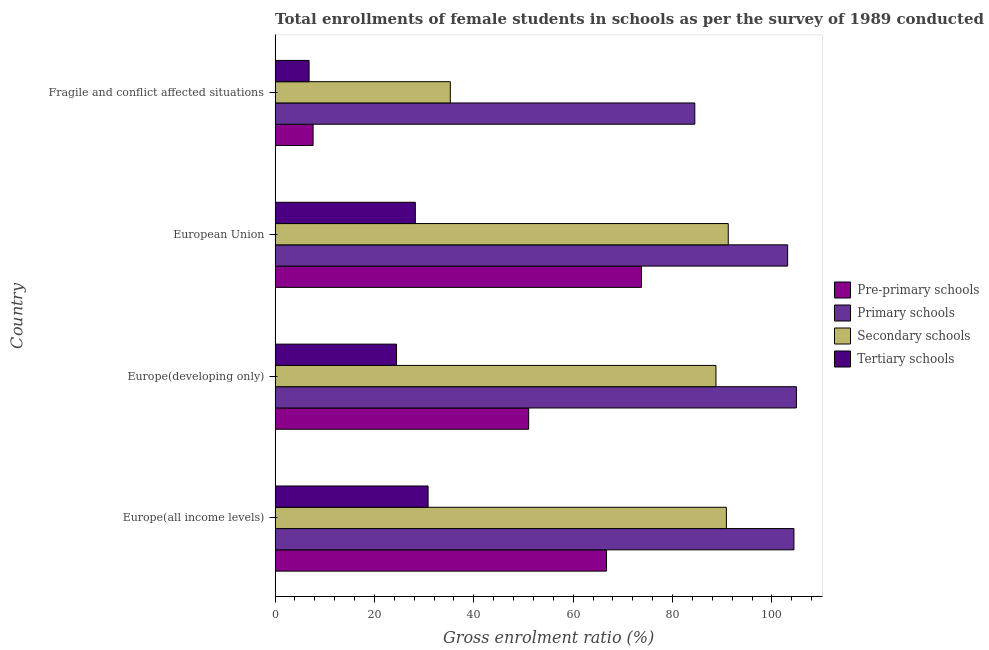Are the number of bars per tick equal to the number of legend labels?
Keep it short and to the point. Yes. How many bars are there on the 1st tick from the top?
Give a very brief answer. 4. What is the label of the 4th group of bars from the top?
Your response must be concise. Europe(all income levels). What is the gross enrolment ratio(female) in tertiary schools in Europe(developing only)?
Your response must be concise. 24.45. Across all countries, what is the maximum gross enrolment ratio(female) in primary schools?
Offer a very short reply. 104.92. Across all countries, what is the minimum gross enrolment ratio(female) in primary schools?
Your answer should be compact. 84.47. In which country was the gross enrolment ratio(female) in primary schools maximum?
Ensure brevity in your answer.  Europe(developing only). In which country was the gross enrolment ratio(female) in tertiary schools minimum?
Provide a short and direct response. Fragile and conflict affected situations. What is the total gross enrolment ratio(female) in pre-primary schools in the graph?
Keep it short and to the point. 199.14. What is the difference between the gross enrolment ratio(female) in primary schools in Europe(all income levels) and that in European Union?
Your answer should be compact. 1.26. What is the difference between the gross enrolment ratio(female) in tertiary schools in Europe(developing only) and the gross enrolment ratio(female) in pre-primary schools in European Union?
Give a very brief answer. -49.29. What is the average gross enrolment ratio(female) in pre-primary schools per country?
Give a very brief answer. 49.78. What is the difference between the gross enrolment ratio(female) in secondary schools and gross enrolment ratio(female) in pre-primary schools in European Union?
Provide a succinct answer. 17.46. In how many countries, is the gross enrolment ratio(female) in secondary schools greater than 16 %?
Provide a succinct answer. 4. What is the ratio of the gross enrolment ratio(female) in pre-primary schools in Europe(all income levels) to that in Europe(developing only)?
Give a very brief answer. 1.31. Is the gross enrolment ratio(female) in pre-primary schools in European Union less than that in Fragile and conflict affected situations?
Provide a succinct answer. No. Is the difference between the gross enrolment ratio(female) in tertiary schools in Europe(developing only) and European Union greater than the difference between the gross enrolment ratio(female) in secondary schools in Europe(developing only) and European Union?
Provide a succinct answer. No. What is the difference between the highest and the second highest gross enrolment ratio(female) in primary schools?
Provide a succinct answer. 0.5. What is the difference between the highest and the lowest gross enrolment ratio(female) in primary schools?
Offer a terse response. 20.45. Is the sum of the gross enrolment ratio(female) in tertiary schools in Europe(all income levels) and Fragile and conflict affected situations greater than the maximum gross enrolment ratio(female) in primary schools across all countries?
Make the answer very short. No. What does the 1st bar from the top in Fragile and conflict affected situations represents?
Provide a succinct answer. Tertiary schools. What does the 3rd bar from the bottom in Europe(developing only) represents?
Provide a succinct answer. Secondary schools. How many bars are there?
Provide a succinct answer. 16. Are all the bars in the graph horizontal?
Provide a succinct answer. Yes. Are the values on the major ticks of X-axis written in scientific E-notation?
Give a very brief answer. No. Where does the legend appear in the graph?
Keep it short and to the point. Center right. How many legend labels are there?
Offer a very short reply. 4. How are the legend labels stacked?
Offer a terse response. Vertical. What is the title of the graph?
Your answer should be very brief. Total enrollments of female students in schools as per the survey of 1989 conducted in different countries. Does "Source data assessment" appear as one of the legend labels in the graph?
Keep it short and to the point. No. What is the label or title of the X-axis?
Offer a terse response. Gross enrolment ratio (%). What is the label or title of the Y-axis?
Offer a terse response. Country. What is the Gross enrolment ratio (%) in Pre-primary schools in Europe(all income levels)?
Provide a short and direct response. 66.71. What is the Gross enrolment ratio (%) of Primary schools in Europe(all income levels)?
Make the answer very short. 104.42. What is the Gross enrolment ratio (%) in Secondary schools in Europe(all income levels)?
Your answer should be compact. 90.83. What is the Gross enrolment ratio (%) of Tertiary schools in Europe(all income levels)?
Your response must be concise. 30.79. What is the Gross enrolment ratio (%) in Pre-primary schools in Europe(developing only)?
Offer a terse response. 51.04. What is the Gross enrolment ratio (%) of Primary schools in Europe(developing only)?
Offer a very short reply. 104.92. What is the Gross enrolment ratio (%) of Secondary schools in Europe(developing only)?
Your response must be concise. 88.73. What is the Gross enrolment ratio (%) in Tertiary schools in Europe(developing only)?
Your answer should be compact. 24.45. What is the Gross enrolment ratio (%) in Pre-primary schools in European Union?
Offer a terse response. 73.74. What is the Gross enrolment ratio (%) in Primary schools in European Union?
Offer a terse response. 103.16. What is the Gross enrolment ratio (%) of Secondary schools in European Union?
Ensure brevity in your answer.  91.2. What is the Gross enrolment ratio (%) of Tertiary schools in European Union?
Provide a succinct answer. 28.23. What is the Gross enrolment ratio (%) of Pre-primary schools in Fragile and conflict affected situations?
Provide a short and direct response. 7.65. What is the Gross enrolment ratio (%) of Primary schools in Fragile and conflict affected situations?
Offer a very short reply. 84.47. What is the Gross enrolment ratio (%) in Secondary schools in Fragile and conflict affected situations?
Give a very brief answer. 35.27. What is the Gross enrolment ratio (%) in Tertiary schools in Fragile and conflict affected situations?
Your response must be concise. 6.84. Across all countries, what is the maximum Gross enrolment ratio (%) of Pre-primary schools?
Offer a very short reply. 73.74. Across all countries, what is the maximum Gross enrolment ratio (%) of Primary schools?
Ensure brevity in your answer.  104.92. Across all countries, what is the maximum Gross enrolment ratio (%) in Secondary schools?
Give a very brief answer. 91.2. Across all countries, what is the maximum Gross enrolment ratio (%) of Tertiary schools?
Offer a very short reply. 30.79. Across all countries, what is the minimum Gross enrolment ratio (%) of Pre-primary schools?
Make the answer very short. 7.65. Across all countries, what is the minimum Gross enrolment ratio (%) in Primary schools?
Offer a very short reply. 84.47. Across all countries, what is the minimum Gross enrolment ratio (%) in Secondary schools?
Make the answer very short. 35.27. Across all countries, what is the minimum Gross enrolment ratio (%) in Tertiary schools?
Provide a short and direct response. 6.84. What is the total Gross enrolment ratio (%) of Pre-primary schools in the graph?
Provide a succinct answer. 199.14. What is the total Gross enrolment ratio (%) of Primary schools in the graph?
Your answer should be compact. 396.97. What is the total Gross enrolment ratio (%) of Secondary schools in the graph?
Make the answer very short. 306.02. What is the total Gross enrolment ratio (%) of Tertiary schools in the graph?
Give a very brief answer. 90.31. What is the difference between the Gross enrolment ratio (%) in Pre-primary schools in Europe(all income levels) and that in Europe(developing only)?
Make the answer very short. 15.67. What is the difference between the Gross enrolment ratio (%) of Primary schools in Europe(all income levels) and that in Europe(developing only)?
Keep it short and to the point. -0.5. What is the difference between the Gross enrolment ratio (%) of Secondary schools in Europe(all income levels) and that in Europe(developing only)?
Your answer should be compact. 2.1. What is the difference between the Gross enrolment ratio (%) in Tertiary schools in Europe(all income levels) and that in Europe(developing only)?
Make the answer very short. 6.35. What is the difference between the Gross enrolment ratio (%) in Pre-primary schools in Europe(all income levels) and that in European Union?
Your response must be concise. -7.03. What is the difference between the Gross enrolment ratio (%) of Primary schools in Europe(all income levels) and that in European Union?
Offer a terse response. 1.26. What is the difference between the Gross enrolment ratio (%) of Secondary schools in Europe(all income levels) and that in European Union?
Your response must be concise. -0.37. What is the difference between the Gross enrolment ratio (%) in Tertiary schools in Europe(all income levels) and that in European Union?
Keep it short and to the point. 2.57. What is the difference between the Gross enrolment ratio (%) in Pre-primary schools in Europe(all income levels) and that in Fragile and conflict affected situations?
Your answer should be very brief. 59.05. What is the difference between the Gross enrolment ratio (%) in Primary schools in Europe(all income levels) and that in Fragile and conflict affected situations?
Offer a very short reply. 19.95. What is the difference between the Gross enrolment ratio (%) in Secondary schools in Europe(all income levels) and that in Fragile and conflict affected situations?
Your answer should be compact. 55.56. What is the difference between the Gross enrolment ratio (%) of Tertiary schools in Europe(all income levels) and that in Fragile and conflict affected situations?
Make the answer very short. 23.95. What is the difference between the Gross enrolment ratio (%) of Pre-primary schools in Europe(developing only) and that in European Union?
Keep it short and to the point. -22.7. What is the difference between the Gross enrolment ratio (%) of Primary schools in Europe(developing only) and that in European Union?
Your answer should be compact. 1.76. What is the difference between the Gross enrolment ratio (%) in Secondary schools in Europe(developing only) and that in European Union?
Give a very brief answer. -2.48. What is the difference between the Gross enrolment ratio (%) of Tertiary schools in Europe(developing only) and that in European Union?
Provide a short and direct response. -3.78. What is the difference between the Gross enrolment ratio (%) in Pre-primary schools in Europe(developing only) and that in Fragile and conflict affected situations?
Your answer should be compact. 43.38. What is the difference between the Gross enrolment ratio (%) in Primary schools in Europe(developing only) and that in Fragile and conflict affected situations?
Ensure brevity in your answer.  20.45. What is the difference between the Gross enrolment ratio (%) of Secondary schools in Europe(developing only) and that in Fragile and conflict affected situations?
Keep it short and to the point. 53.46. What is the difference between the Gross enrolment ratio (%) in Tertiary schools in Europe(developing only) and that in Fragile and conflict affected situations?
Your answer should be very brief. 17.6. What is the difference between the Gross enrolment ratio (%) of Pre-primary schools in European Union and that in Fragile and conflict affected situations?
Ensure brevity in your answer.  66.09. What is the difference between the Gross enrolment ratio (%) in Primary schools in European Union and that in Fragile and conflict affected situations?
Your answer should be very brief. 18.69. What is the difference between the Gross enrolment ratio (%) in Secondary schools in European Union and that in Fragile and conflict affected situations?
Your answer should be very brief. 55.94. What is the difference between the Gross enrolment ratio (%) of Tertiary schools in European Union and that in Fragile and conflict affected situations?
Your answer should be compact. 21.38. What is the difference between the Gross enrolment ratio (%) of Pre-primary schools in Europe(all income levels) and the Gross enrolment ratio (%) of Primary schools in Europe(developing only)?
Keep it short and to the point. -38.21. What is the difference between the Gross enrolment ratio (%) in Pre-primary schools in Europe(all income levels) and the Gross enrolment ratio (%) in Secondary schools in Europe(developing only)?
Provide a succinct answer. -22.02. What is the difference between the Gross enrolment ratio (%) in Pre-primary schools in Europe(all income levels) and the Gross enrolment ratio (%) in Tertiary schools in Europe(developing only)?
Offer a terse response. 42.26. What is the difference between the Gross enrolment ratio (%) of Primary schools in Europe(all income levels) and the Gross enrolment ratio (%) of Secondary schools in Europe(developing only)?
Your answer should be compact. 15.69. What is the difference between the Gross enrolment ratio (%) of Primary schools in Europe(all income levels) and the Gross enrolment ratio (%) of Tertiary schools in Europe(developing only)?
Your response must be concise. 79.98. What is the difference between the Gross enrolment ratio (%) in Secondary schools in Europe(all income levels) and the Gross enrolment ratio (%) in Tertiary schools in Europe(developing only)?
Keep it short and to the point. 66.39. What is the difference between the Gross enrolment ratio (%) of Pre-primary schools in Europe(all income levels) and the Gross enrolment ratio (%) of Primary schools in European Union?
Provide a short and direct response. -36.45. What is the difference between the Gross enrolment ratio (%) of Pre-primary schools in Europe(all income levels) and the Gross enrolment ratio (%) of Secondary schools in European Union?
Make the answer very short. -24.5. What is the difference between the Gross enrolment ratio (%) in Pre-primary schools in Europe(all income levels) and the Gross enrolment ratio (%) in Tertiary schools in European Union?
Your answer should be compact. 38.48. What is the difference between the Gross enrolment ratio (%) of Primary schools in Europe(all income levels) and the Gross enrolment ratio (%) of Secondary schools in European Union?
Your response must be concise. 13.22. What is the difference between the Gross enrolment ratio (%) of Primary schools in Europe(all income levels) and the Gross enrolment ratio (%) of Tertiary schools in European Union?
Provide a succinct answer. 76.19. What is the difference between the Gross enrolment ratio (%) in Secondary schools in Europe(all income levels) and the Gross enrolment ratio (%) in Tertiary schools in European Union?
Provide a succinct answer. 62.6. What is the difference between the Gross enrolment ratio (%) in Pre-primary schools in Europe(all income levels) and the Gross enrolment ratio (%) in Primary schools in Fragile and conflict affected situations?
Your response must be concise. -17.77. What is the difference between the Gross enrolment ratio (%) in Pre-primary schools in Europe(all income levels) and the Gross enrolment ratio (%) in Secondary schools in Fragile and conflict affected situations?
Keep it short and to the point. 31.44. What is the difference between the Gross enrolment ratio (%) of Pre-primary schools in Europe(all income levels) and the Gross enrolment ratio (%) of Tertiary schools in Fragile and conflict affected situations?
Your answer should be compact. 59.86. What is the difference between the Gross enrolment ratio (%) in Primary schools in Europe(all income levels) and the Gross enrolment ratio (%) in Secondary schools in Fragile and conflict affected situations?
Your answer should be very brief. 69.16. What is the difference between the Gross enrolment ratio (%) of Primary schools in Europe(all income levels) and the Gross enrolment ratio (%) of Tertiary schools in Fragile and conflict affected situations?
Make the answer very short. 97.58. What is the difference between the Gross enrolment ratio (%) in Secondary schools in Europe(all income levels) and the Gross enrolment ratio (%) in Tertiary schools in Fragile and conflict affected situations?
Your answer should be compact. 83.99. What is the difference between the Gross enrolment ratio (%) of Pre-primary schools in Europe(developing only) and the Gross enrolment ratio (%) of Primary schools in European Union?
Your response must be concise. -52.12. What is the difference between the Gross enrolment ratio (%) of Pre-primary schools in Europe(developing only) and the Gross enrolment ratio (%) of Secondary schools in European Union?
Make the answer very short. -40.17. What is the difference between the Gross enrolment ratio (%) in Pre-primary schools in Europe(developing only) and the Gross enrolment ratio (%) in Tertiary schools in European Union?
Provide a short and direct response. 22.81. What is the difference between the Gross enrolment ratio (%) of Primary schools in Europe(developing only) and the Gross enrolment ratio (%) of Secondary schools in European Union?
Provide a succinct answer. 13.72. What is the difference between the Gross enrolment ratio (%) in Primary schools in Europe(developing only) and the Gross enrolment ratio (%) in Tertiary schools in European Union?
Keep it short and to the point. 76.69. What is the difference between the Gross enrolment ratio (%) in Secondary schools in Europe(developing only) and the Gross enrolment ratio (%) in Tertiary schools in European Union?
Give a very brief answer. 60.5. What is the difference between the Gross enrolment ratio (%) in Pre-primary schools in Europe(developing only) and the Gross enrolment ratio (%) in Primary schools in Fragile and conflict affected situations?
Ensure brevity in your answer.  -33.44. What is the difference between the Gross enrolment ratio (%) in Pre-primary schools in Europe(developing only) and the Gross enrolment ratio (%) in Secondary schools in Fragile and conflict affected situations?
Your response must be concise. 15.77. What is the difference between the Gross enrolment ratio (%) in Pre-primary schools in Europe(developing only) and the Gross enrolment ratio (%) in Tertiary schools in Fragile and conflict affected situations?
Your response must be concise. 44.19. What is the difference between the Gross enrolment ratio (%) in Primary schools in Europe(developing only) and the Gross enrolment ratio (%) in Secondary schools in Fragile and conflict affected situations?
Give a very brief answer. 69.65. What is the difference between the Gross enrolment ratio (%) in Primary schools in Europe(developing only) and the Gross enrolment ratio (%) in Tertiary schools in Fragile and conflict affected situations?
Your response must be concise. 98.07. What is the difference between the Gross enrolment ratio (%) in Secondary schools in Europe(developing only) and the Gross enrolment ratio (%) in Tertiary schools in Fragile and conflict affected situations?
Make the answer very short. 81.88. What is the difference between the Gross enrolment ratio (%) of Pre-primary schools in European Union and the Gross enrolment ratio (%) of Primary schools in Fragile and conflict affected situations?
Ensure brevity in your answer.  -10.73. What is the difference between the Gross enrolment ratio (%) in Pre-primary schools in European Union and the Gross enrolment ratio (%) in Secondary schools in Fragile and conflict affected situations?
Offer a very short reply. 38.47. What is the difference between the Gross enrolment ratio (%) in Pre-primary schools in European Union and the Gross enrolment ratio (%) in Tertiary schools in Fragile and conflict affected situations?
Make the answer very short. 66.9. What is the difference between the Gross enrolment ratio (%) in Primary schools in European Union and the Gross enrolment ratio (%) in Secondary schools in Fragile and conflict affected situations?
Offer a terse response. 67.89. What is the difference between the Gross enrolment ratio (%) in Primary schools in European Union and the Gross enrolment ratio (%) in Tertiary schools in Fragile and conflict affected situations?
Give a very brief answer. 96.31. What is the difference between the Gross enrolment ratio (%) of Secondary schools in European Union and the Gross enrolment ratio (%) of Tertiary schools in Fragile and conflict affected situations?
Offer a terse response. 84.36. What is the average Gross enrolment ratio (%) of Pre-primary schools per country?
Ensure brevity in your answer.  49.78. What is the average Gross enrolment ratio (%) in Primary schools per country?
Your response must be concise. 99.24. What is the average Gross enrolment ratio (%) in Secondary schools per country?
Keep it short and to the point. 76.51. What is the average Gross enrolment ratio (%) of Tertiary schools per country?
Your response must be concise. 22.58. What is the difference between the Gross enrolment ratio (%) of Pre-primary schools and Gross enrolment ratio (%) of Primary schools in Europe(all income levels)?
Your response must be concise. -37.72. What is the difference between the Gross enrolment ratio (%) of Pre-primary schools and Gross enrolment ratio (%) of Secondary schools in Europe(all income levels)?
Your answer should be compact. -24.12. What is the difference between the Gross enrolment ratio (%) in Pre-primary schools and Gross enrolment ratio (%) in Tertiary schools in Europe(all income levels)?
Your answer should be compact. 35.91. What is the difference between the Gross enrolment ratio (%) of Primary schools and Gross enrolment ratio (%) of Secondary schools in Europe(all income levels)?
Make the answer very short. 13.59. What is the difference between the Gross enrolment ratio (%) in Primary schools and Gross enrolment ratio (%) in Tertiary schools in Europe(all income levels)?
Your answer should be compact. 73.63. What is the difference between the Gross enrolment ratio (%) of Secondary schools and Gross enrolment ratio (%) of Tertiary schools in Europe(all income levels)?
Provide a succinct answer. 60.04. What is the difference between the Gross enrolment ratio (%) of Pre-primary schools and Gross enrolment ratio (%) of Primary schools in Europe(developing only)?
Provide a succinct answer. -53.88. What is the difference between the Gross enrolment ratio (%) in Pre-primary schools and Gross enrolment ratio (%) in Secondary schools in Europe(developing only)?
Ensure brevity in your answer.  -37.69. What is the difference between the Gross enrolment ratio (%) in Pre-primary schools and Gross enrolment ratio (%) in Tertiary schools in Europe(developing only)?
Your response must be concise. 26.59. What is the difference between the Gross enrolment ratio (%) in Primary schools and Gross enrolment ratio (%) in Secondary schools in Europe(developing only)?
Your answer should be very brief. 16.19. What is the difference between the Gross enrolment ratio (%) of Primary schools and Gross enrolment ratio (%) of Tertiary schools in Europe(developing only)?
Offer a terse response. 80.47. What is the difference between the Gross enrolment ratio (%) of Secondary schools and Gross enrolment ratio (%) of Tertiary schools in Europe(developing only)?
Provide a succinct answer. 64.28. What is the difference between the Gross enrolment ratio (%) in Pre-primary schools and Gross enrolment ratio (%) in Primary schools in European Union?
Provide a succinct answer. -29.42. What is the difference between the Gross enrolment ratio (%) in Pre-primary schools and Gross enrolment ratio (%) in Secondary schools in European Union?
Offer a terse response. -17.46. What is the difference between the Gross enrolment ratio (%) of Pre-primary schools and Gross enrolment ratio (%) of Tertiary schools in European Union?
Make the answer very short. 45.51. What is the difference between the Gross enrolment ratio (%) of Primary schools and Gross enrolment ratio (%) of Secondary schools in European Union?
Keep it short and to the point. 11.96. What is the difference between the Gross enrolment ratio (%) of Primary schools and Gross enrolment ratio (%) of Tertiary schools in European Union?
Offer a very short reply. 74.93. What is the difference between the Gross enrolment ratio (%) of Secondary schools and Gross enrolment ratio (%) of Tertiary schools in European Union?
Give a very brief answer. 62.98. What is the difference between the Gross enrolment ratio (%) in Pre-primary schools and Gross enrolment ratio (%) in Primary schools in Fragile and conflict affected situations?
Offer a terse response. -76.82. What is the difference between the Gross enrolment ratio (%) in Pre-primary schools and Gross enrolment ratio (%) in Secondary schools in Fragile and conflict affected situations?
Offer a terse response. -27.61. What is the difference between the Gross enrolment ratio (%) of Pre-primary schools and Gross enrolment ratio (%) of Tertiary schools in Fragile and conflict affected situations?
Provide a succinct answer. 0.81. What is the difference between the Gross enrolment ratio (%) in Primary schools and Gross enrolment ratio (%) in Secondary schools in Fragile and conflict affected situations?
Your response must be concise. 49.21. What is the difference between the Gross enrolment ratio (%) of Primary schools and Gross enrolment ratio (%) of Tertiary schools in Fragile and conflict affected situations?
Give a very brief answer. 77.63. What is the difference between the Gross enrolment ratio (%) in Secondary schools and Gross enrolment ratio (%) in Tertiary schools in Fragile and conflict affected situations?
Offer a terse response. 28.42. What is the ratio of the Gross enrolment ratio (%) of Pre-primary schools in Europe(all income levels) to that in Europe(developing only)?
Your answer should be compact. 1.31. What is the ratio of the Gross enrolment ratio (%) in Primary schools in Europe(all income levels) to that in Europe(developing only)?
Offer a terse response. 1. What is the ratio of the Gross enrolment ratio (%) in Secondary schools in Europe(all income levels) to that in Europe(developing only)?
Your answer should be compact. 1.02. What is the ratio of the Gross enrolment ratio (%) in Tertiary schools in Europe(all income levels) to that in Europe(developing only)?
Your response must be concise. 1.26. What is the ratio of the Gross enrolment ratio (%) of Pre-primary schools in Europe(all income levels) to that in European Union?
Offer a terse response. 0.9. What is the ratio of the Gross enrolment ratio (%) in Primary schools in Europe(all income levels) to that in European Union?
Keep it short and to the point. 1.01. What is the ratio of the Gross enrolment ratio (%) of Tertiary schools in Europe(all income levels) to that in European Union?
Make the answer very short. 1.09. What is the ratio of the Gross enrolment ratio (%) of Pre-primary schools in Europe(all income levels) to that in Fragile and conflict affected situations?
Provide a short and direct response. 8.72. What is the ratio of the Gross enrolment ratio (%) of Primary schools in Europe(all income levels) to that in Fragile and conflict affected situations?
Your answer should be very brief. 1.24. What is the ratio of the Gross enrolment ratio (%) of Secondary schools in Europe(all income levels) to that in Fragile and conflict affected situations?
Your answer should be very brief. 2.58. What is the ratio of the Gross enrolment ratio (%) of Tertiary schools in Europe(all income levels) to that in Fragile and conflict affected situations?
Offer a very short reply. 4.5. What is the ratio of the Gross enrolment ratio (%) in Pre-primary schools in Europe(developing only) to that in European Union?
Your answer should be very brief. 0.69. What is the ratio of the Gross enrolment ratio (%) of Primary schools in Europe(developing only) to that in European Union?
Your response must be concise. 1.02. What is the ratio of the Gross enrolment ratio (%) in Secondary schools in Europe(developing only) to that in European Union?
Keep it short and to the point. 0.97. What is the ratio of the Gross enrolment ratio (%) of Tertiary schools in Europe(developing only) to that in European Union?
Your answer should be compact. 0.87. What is the ratio of the Gross enrolment ratio (%) of Pre-primary schools in Europe(developing only) to that in Fragile and conflict affected situations?
Offer a very short reply. 6.67. What is the ratio of the Gross enrolment ratio (%) in Primary schools in Europe(developing only) to that in Fragile and conflict affected situations?
Keep it short and to the point. 1.24. What is the ratio of the Gross enrolment ratio (%) in Secondary schools in Europe(developing only) to that in Fragile and conflict affected situations?
Provide a succinct answer. 2.52. What is the ratio of the Gross enrolment ratio (%) of Tertiary schools in Europe(developing only) to that in Fragile and conflict affected situations?
Offer a very short reply. 3.57. What is the ratio of the Gross enrolment ratio (%) in Pre-primary schools in European Union to that in Fragile and conflict affected situations?
Make the answer very short. 9.63. What is the ratio of the Gross enrolment ratio (%) in Primary schools in European Union to that in Fragile and conflict affected situations?
Ensure brevity in your answer.  1.22. What is the ratio of the Gross enrolment ratio (%) in Secondary schools in European Union to that in Fragile and conflict affected situations?
Offer a terse response. 2.59. What is the ratio of the Gross enrolment ratio (%) in Tertiary schools in European Union to that in Fragile and conflict affected situations?
Your response must be concise. 4.12. What is the difference between the highest and the second highest Gross enrolment ratio (%) of Pre-primary schools?
Keep it short and to the point. 7.03. What is the difference between the highest and the second highest Gross enrolment ratio (%) of Primary schools?
Offer a very short reply. 0.5. What is the difference between the highest and the second highest Gross enrolment ratio (%) of Secondary schools?
Keep it short and to the point. 0.37. What is the difference between the highest and the second highest Gross enrolment ratio (%) of Tertiary schools?
Your answer should be compact. 2.57. What is the difference between the highest and the lowest Gross enrolment ratio (%) of Pre-primary schools?
Make the answer very short. 66.09. What is the difference between the highest and the lowest Gross enrolment ratio (%) in Primary schools?
Your answer should be compact. 20.45. What is the difference between the highest and the lowest Gross enrolment ratio (%) of Secondary schools?
Your response must be concise. 55.94. What is the difference between the highest and the lowest Gross enrolment ratio (%) of Tertiary schools?
Your answer should be compact. 23.95. 